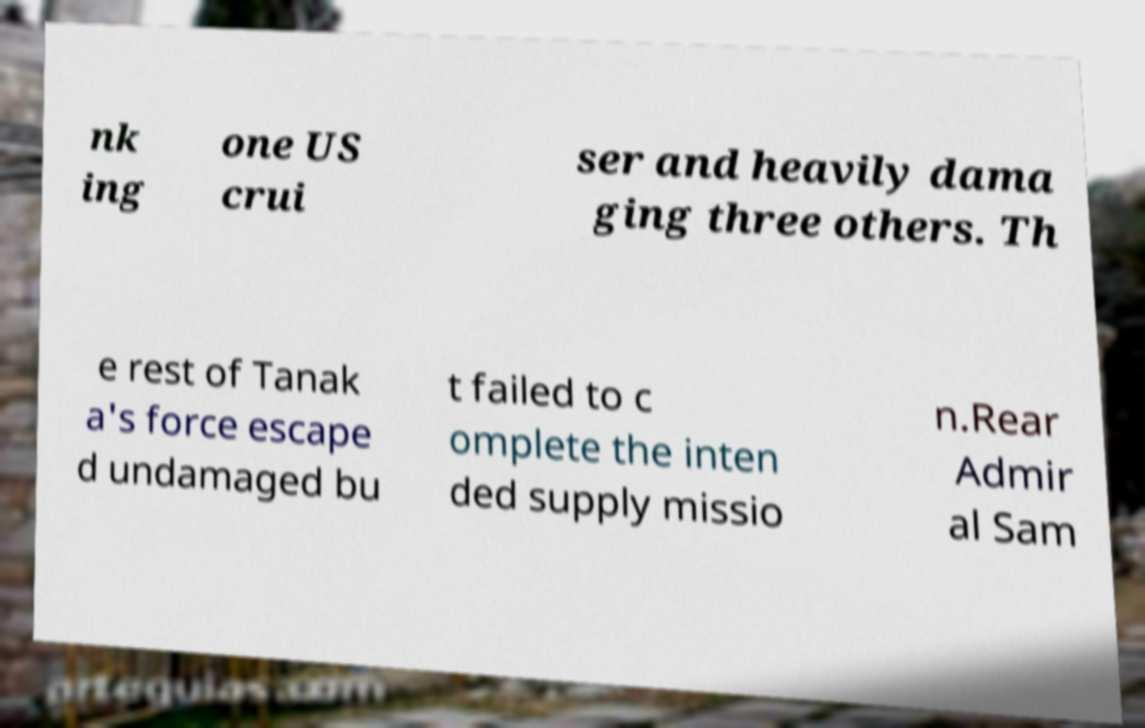Can you read and provide the text displayed in the image?This photo seems to have some interesting text. Can you extract and type it out for me? nk ing one US crui ser and heavily dama ging three others. Th e rest of Tanak a's force escape d undamaged bu t failed to c omplete the inten ded supply missio n.Rear Admir al Sam 